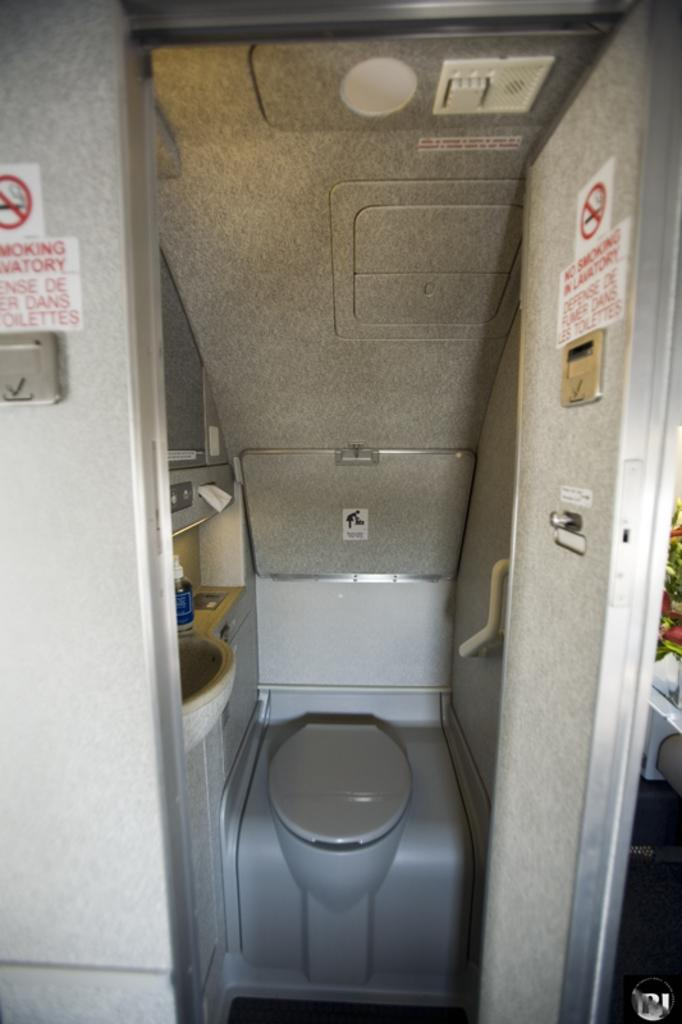<image>
Offer a succinct explanation of the picture presented. a room with the word lavatory on it 